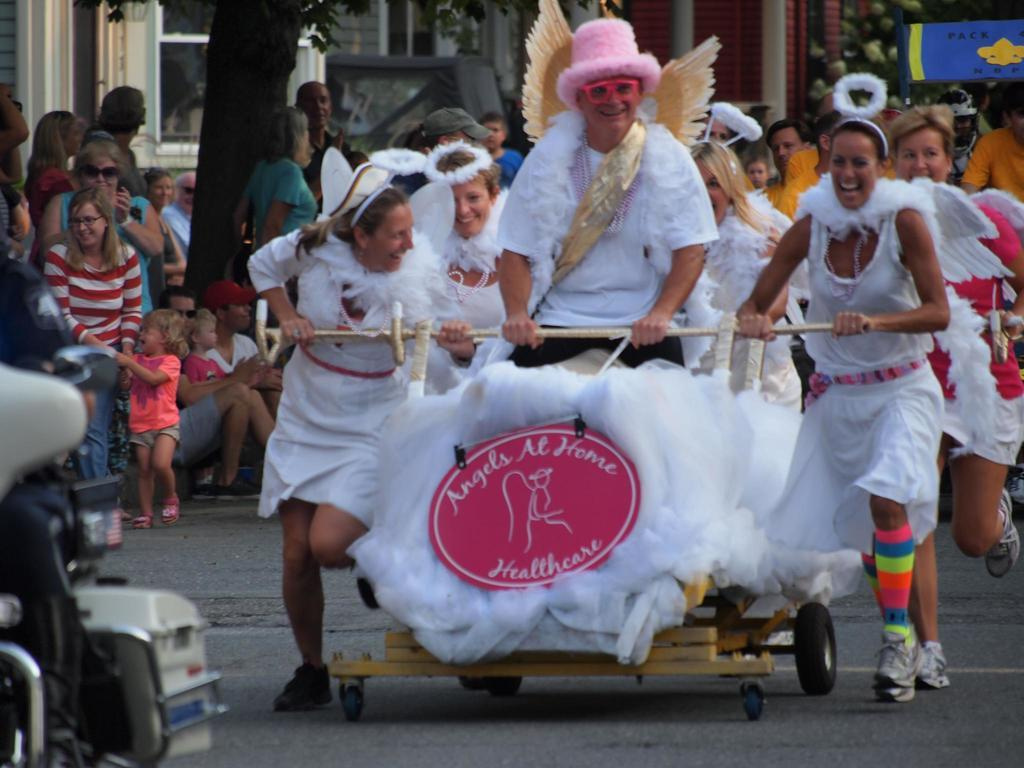What can be seen in the foreground of the picture? There are people and a cart in the foreground of the picture. What is located on the left side of the picture? There is a motorbike on the left side of the picture. What is visible in the background of the picture? There are people, trees, and buildings in the background of the picture. How much money is being exchanged in the market in the image? There is no market present in the image, and therefore no money exchange can be observed. What type of trouble are the people in the background facing? There is no indication of trouble in the image; the people in the background are simply present. 